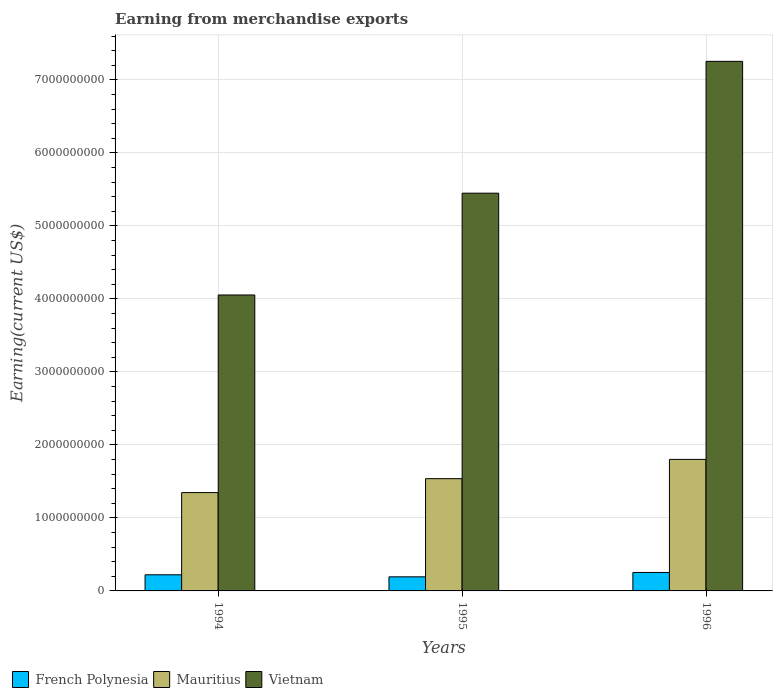How many groups of bars are there?
Your response must be concise. 3. Are the number of bars on each tick of the X-axis equal?
Keep it short and to the point. Yes. In how many cases, is the number of bars for a given year not equal to the number of legend labels?
Your response must be concise. 0. What is the amount earned from merchandise exports in Mauritius in 1996?
Ensure brevity in your answer.  1.80e+09. Across all years, what is the maximum amount earned from merchandise exports in French Polynesia?
Keep it short and to the point. 2.53e+08. Across all years, what is the minimum amount earned from merchandise exports in Mauritius?
Offer a terse response. 1.35e+09. In which year was the amount earned from merchandise exports in Mauritius maximum?
Provide a short and direct response. 1996. In which year was the amount earned from merchandise exports in Mauritius minimum?
Ensure brevity in your answer.  1994. What is the total amount earned from merchandise exports in French Polynesia in the graph?
Keep it short and to the point. 6.67e+08. What is the difference between the amount earned from merchandise exports in Vietnam in 1995 and that in 1996?
Keep it short and to the point. -1.81e+09. What is the difference between the amount earned from merchandise exports in French Polynesia in 1996 and the amount earned from merchandise exports in Mauritius in 1995?
Ensure brevity in your answer.  -1.28e+09. What is the average amount earned from merchandise exports in Vietnam per year?
Offer a terse response. 5.59e+09. In the year 1994, what is the difference between the amount earned from merchandise exports in French Polynesia and amount earned from merchandise exports in Vietnam?
Offer a terse response. -3.83e+09. What is the ratio of the amount earned from merchandise exports in Vietnam in 1994 to that in 1996?
Your answer should be very brief. 0.56. Is the difference between the amount earned from merchandise exports in French Polynesia in 1995 and 1996 greater than the difference between the amount earned from merchandise exports in Vietnam in 1995 and 1996?
Provide a short and direct response. Yes. What is the difference between the highest and the second highest amount earned from merchandise exports in Vietnam?
Ensure brevity in your answer.  1.81e+09. What is the difference between the highest and the lowest amount earned from merchandise exports in Mauritius?
Your answer should be very brief. 4.55e+08. In how many years, is the amount earned from merchandise exports in Mauritius greater than the average amount earned from merchandise exports in Mauritius taken over all years?
Provide a succinct answer. 1. What does the 2nd bar from the left in 1996 represents?
Your answer should be very brief. Mauritius. What does the 3rd bar from the right in 1994 represents?
Keep it short and to the point. French Polynesia. Is it the case that in every year, the sum of the amount earned from merchandise exports in Vietnam and amount earned from merchandise exports in French Polynesia is greater than the amount earned from merchandise exports in Mauritius?
Give a very brief answer. Yes. How many bars are there?
Your answer should be very brief. 9. How many years are there in the graph?
Offer a very short reply. 3. What is the difference between two consecutive major ticks on the Y-axis?
Your answer should be compact. 1.00e+09. Are the values on the major ticks of Y-axis written in scientific E-notation?
Provide a succinct answer. No. Does the graph contain any zero values?
Provide a succinct answer. No. Does the graph contain grids?
Make the answer very short. Yes. Where does the legend appear in the graph?
Make the answer very short. Bottom left. What is the title of the graph?
Offer a very short reply. Earning from merchandise exports. Does "Vietnam" appear as one of the legend labels in the graph?
Ensure brevity in your answer.  Yes. What is the label or title of the Y-axis?
Your answer should be very brief. Earning(current US$). What is the Earning(current US$) in French Polynesia in 1994?
Your response must be concise. 2.21e+08. What is the Earning(current US$) in Mauritius in 1994?
Make the answer very short. 1.35e+09. What is the Earning(current US$) in Vietnam in 1994?
Your answer should be compact. 4.05e+09. What is the Earning(current US$) in French Polynesia in 1995?
Give a very brief answer. 1.93e+08. What is the Earning(current US$) of Mauritius in 1995?
Your response must be concise. 1.54e+09. What is the Earning(current US$) of Vietnam in 1995?
Offer a terse response. 5.45e+09. What is the Earning(current US$) in French Polynesia in 1996?
Make the answer very short. 2.53e+08. What is the Earning(current US$) of Mauritius in 1996?
Make the answer very short. 1.80e+09. What is the Earning(current US$) of Vietnam in 1996?
Make the answer very short. 7.26e+09. Across all years, what is the maximum Earning(current US$) of French Polynesia?
Make the answer very short. 2.53e+08. Across all years, what is the maximum Earning(current US$) of Mauritius?
Keep it short and to the point. 1.80e+09. Across all years, what is the maximum Earning(current US$) in Vietnam?
Offer a very short reply. 7.26e+09. Across all years, what is the minimum Earning(current US$) of French Polynesia?
Your answer should be very brief. 1.93e+08. Across all years, what is the minimum Earning(current US$) in Mauritius?
Ensure brevity in your answer.  1.35e+09. Across all years, what is the minimum Earning(current US$) of Vietnam?
Offer a terse response. 4.05e+09. What is the total Earning(current US$) in French Polynesia in the graph?
Provide a succinct answer. 6.67e+08. What is the total Earning(current US$) in Mauritius in the graph?
Ensure brevity in your answer.  4.69e+09. What is the total Earning(current US$) of Vietnam in the graph?
Provide a succinct answer. 1.68e+1. What is the difference between the Earning(current US$) in French Polynesia in 1994 and that in 1995?
Give a very brief answer. 2.80e+07. What is the difference between the Earning(current US$) of Mauritius in 1994 and that in 1995?
Give a very brief answer. -1.91e+08. What is the difference between the Earning(current US$) in Vietnam in 1994 and that in 1995?
Provide a succinct answer. -1.39e+09. What is the difference between the Earning(current US$) of French Polynesia in 1994 and that in 1996?
Your answer should be compact. -3.20e+07. What is the difference between the Earning(current US$) in Mauritius in 1994 and that in 1996?
Your answer should be compact. -4.55e+08. What is the difference between the Earning(current US$) of Vietnam in 1994 and that in 1996?
Offer a very short reply. -3.20e+09. What is the difference between the Earning(current US$) of French Polynesia in 1995 and that in 1996?
Your answer should be compact. -6.00e+07. What is the difference between the Earning(current US$) in Mauritius in 1995 and that in 1996?
Provide a succinct answer. -2.64e+08. What is the difference between the Earning(current US$) of Vietnam in 1995 and that in 1996?
Ensure brevity in your answer.  -1.81e+09. What is the difference between the Earning(current US$) of French Polynesia in 1994 and the Earning(current US$) of Mauritius in 1995?
Give a very brief answer. -1.32e+09. What is the difference between the Earning(current US$) of French Polynesia in 1994 and the Earning(current US$) of Vietnam in 1995?
Ensure brevity in your answer.  -5.23e+09. What is the difference between the Earning(current US$) in Mauritius in 1994 and the Earning(current US$) in Vietnam in 1995?
Your answer should be very brief. -4.10e+09. What is the difference between the Earning(current US$) in French Polynesia in 1994 and the Earning(current US$) in Mauritius in 1996?
Provide a short and direct response. -1.58e+09. What is the difference between the Earning(current US$) in French Polynesia in 1994 and the Earning(current US$) in Vietnam in 1996?
Offer a terse response. -7.03e+09. What is the difference between the Earning(current US$) of Mauritius in 1994 and the Earning(current US$) of Vietnam in 1996?
Keep it short and to the point. -5.91e+09. What is the difference between the Earning(current US$) of French Polynesia in 1995 and the Earning(current US$) of Mauritius in 1996?
Your response must be concise. -1.61e+09. What is the difference between the Earning(current US$) of French Polynesia in 1995 and the Earning(current US$) of Vietnam in 1996?
Offer a very short reply. -7.06e+09. What is the difference between the Earning(current US$) of Mauritius in 1995 and the Earning(current US$) of Vietnam in 1996?
Ensure brevity in your answer.  -5.72e+09. What is the average Earning(current US$) of French Polynesia per year?
Give a very brief answer. 2.22e+08. What is the average Earning(current US$) in Mauritius per year?
Offer a very short reply. 1.56e+09. What is the average Earning(current US$) in Vietnam per year?
Provide a short and direct response. 5.59e+09. In the year 1994, what is the difference between the Earning(current US$) in French Polynesia and Earning(current US$) in Mauritius?
Provide a short and direct response. -1.13e+09. In the year 1994, what is the difference between the Earning(current US$) of French Polynesia and Earning(current US$) of Vietnam?
Make the answer very short. -3.83e+09. In the year 1994, what is the difference between the Earning(current US$) of Mauritius and Earning(current US$) of Vietnam?
Make the answer very short. -2.71e+09. In the year 1995, what is the difference between the Earning(current US$) of French Polynesia and Earning(current US$) of Mauritius?
Your answer should be very brief. -1.34e+09. In the year 1995, what is the difference between the Earning(current US$) of French Polynesia and Earning(current US$) of Vietnam?
Keep it short and to the point. -5.26e+09. In the year 1995, what is the difference between the Earning(current US$) of Mauritius and Earning(current US$) of Vietnam?
Your answer should be compact. -3.91e+09. In the year 1996, what is the difference between the Earning(current US$) in French Polynesia and Earning(current US$) in Mauritius?
Give a very brief answer. -1.55e+09. In the year 1996, what is the difference between the Earning(current US$) of French Polynesia and Earning(current US$) of Vietnam?
Offer a terse response. -7.00e+09. In the year 1996, what is the difference between the Earning(current US$) in Mauritius and Earning(current US$) in Vietnam?
Make the answer very short. -5.45e+09. What is the ratio of the Earning(current US$) in French Polynesia in 1994 to that in 1995?
Your answer should be very brief. 1.15. What is the ratio of the Earning(current US$) in Mauritius in 1994 to that in 1995?
Ensure brevity in your answer.  0.88. What is the ratio of the Earning(current US$) of Vietnam in 1994 to that in 1995?
Offer a terse response. 0.74. What is the ratio of the Earning(current US$) of French Polynesia in 1994 to that in 1996?
Keep it short and to the point. 0.87. What is the ratio of the Earning(current US$) of Mauritius in 1994 to that in 1996?
Offer a very short reply. 0.75. What is the ratio of the Earning(current US$) in Vietnam in 1994 to that in 1996?
Keep it short and to the point. 0.56. What is the ratio of the Earning(current US$) of French Polynesia in 1995 to that in 1996?
Keep it short and to the point. 0.76. What is the ratio of the Earning(current US$) of Mauritius in 1995 to that in 1996?
Offer a terse response. 0.85. What is the ratio of the Earning(current US$) of Vietnam in 1995 to that in 1996?
Provide a succinct answer. 0.75. What is the difference between the highest and the second highest Earning(current US$) of French Polynesia?
Your response must be concise. 3.20e+07. What is the difference between the highest and the second highest Earning(current US$) of Mauritius?
Provide a succinct answer. 2.64e+08. What is the difference between the highest and the second highest Earning(current US$) in Vietnam?
Give a very brief answer. 1.81e+09. What is the difference between the highest and the lowest Earning(current US$) in French Polynesia?
Ensure brevity in your answer.  6.00e+07. What is the difference between the highest and the lowest Earning(current US$) in Mauritius?
Provide a short and direct response. 4.55e+08. What is the difference between the highest and the lowest Earning(current US$) of Vietnam?
Your answer should be very brief. 3.20e+09. 